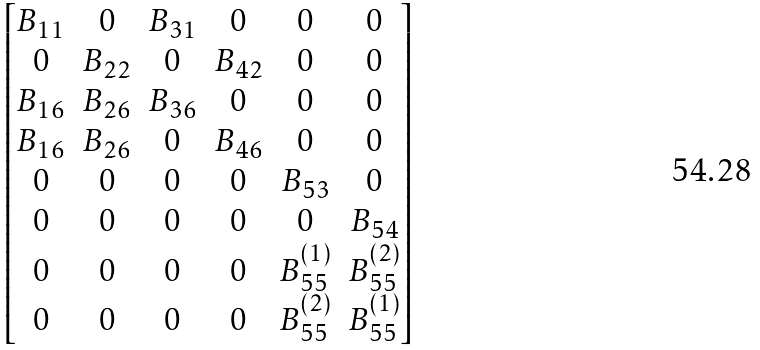<formula> <loc_0><loc_0><loc_500><loc_500>\begin{bmatrix} B _ { 1 1 } & 0 & B _ { 3 1 } & 0 & 0 & 0 \\ 0 & B _ { 2 2 } & 0 & B _ { 4 2 } & 0 & 0 \\ B _ { 1 6 } & B _ { 2 6 } & B _ { 3 6 } & 0 & 0 & 0 \\ B _ { 1 6 } & B _ { 2 6 } & 0 & B _ { 4 6 } & 0 & 0 \\ 0 & 0 & 0 & 0 & B _ { 5 3 } & 0 \\ 0 & 0 & 0 & 0 & 0 & B _ { 5 4 } \\ 0 & 0 & 0 & 0 & B _ { 5 5 } ^ { ( 1 ) } & B _ { 5 5 } ^ { ( 2 ) } \\ 0 & 0 & 0 & 0 & B _ { 5 5 } ^ { ( 2 ) } & B _ { 5 5 } ^ { ( 1 ) } \end{bmatrix}</formula> 